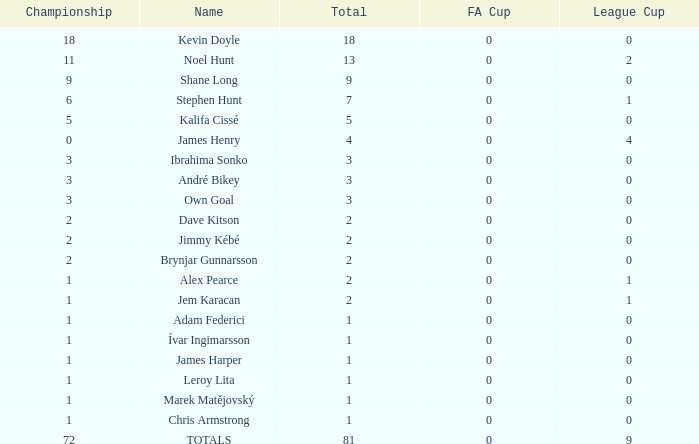What is the total championships that the league cup is less than 0? None. 